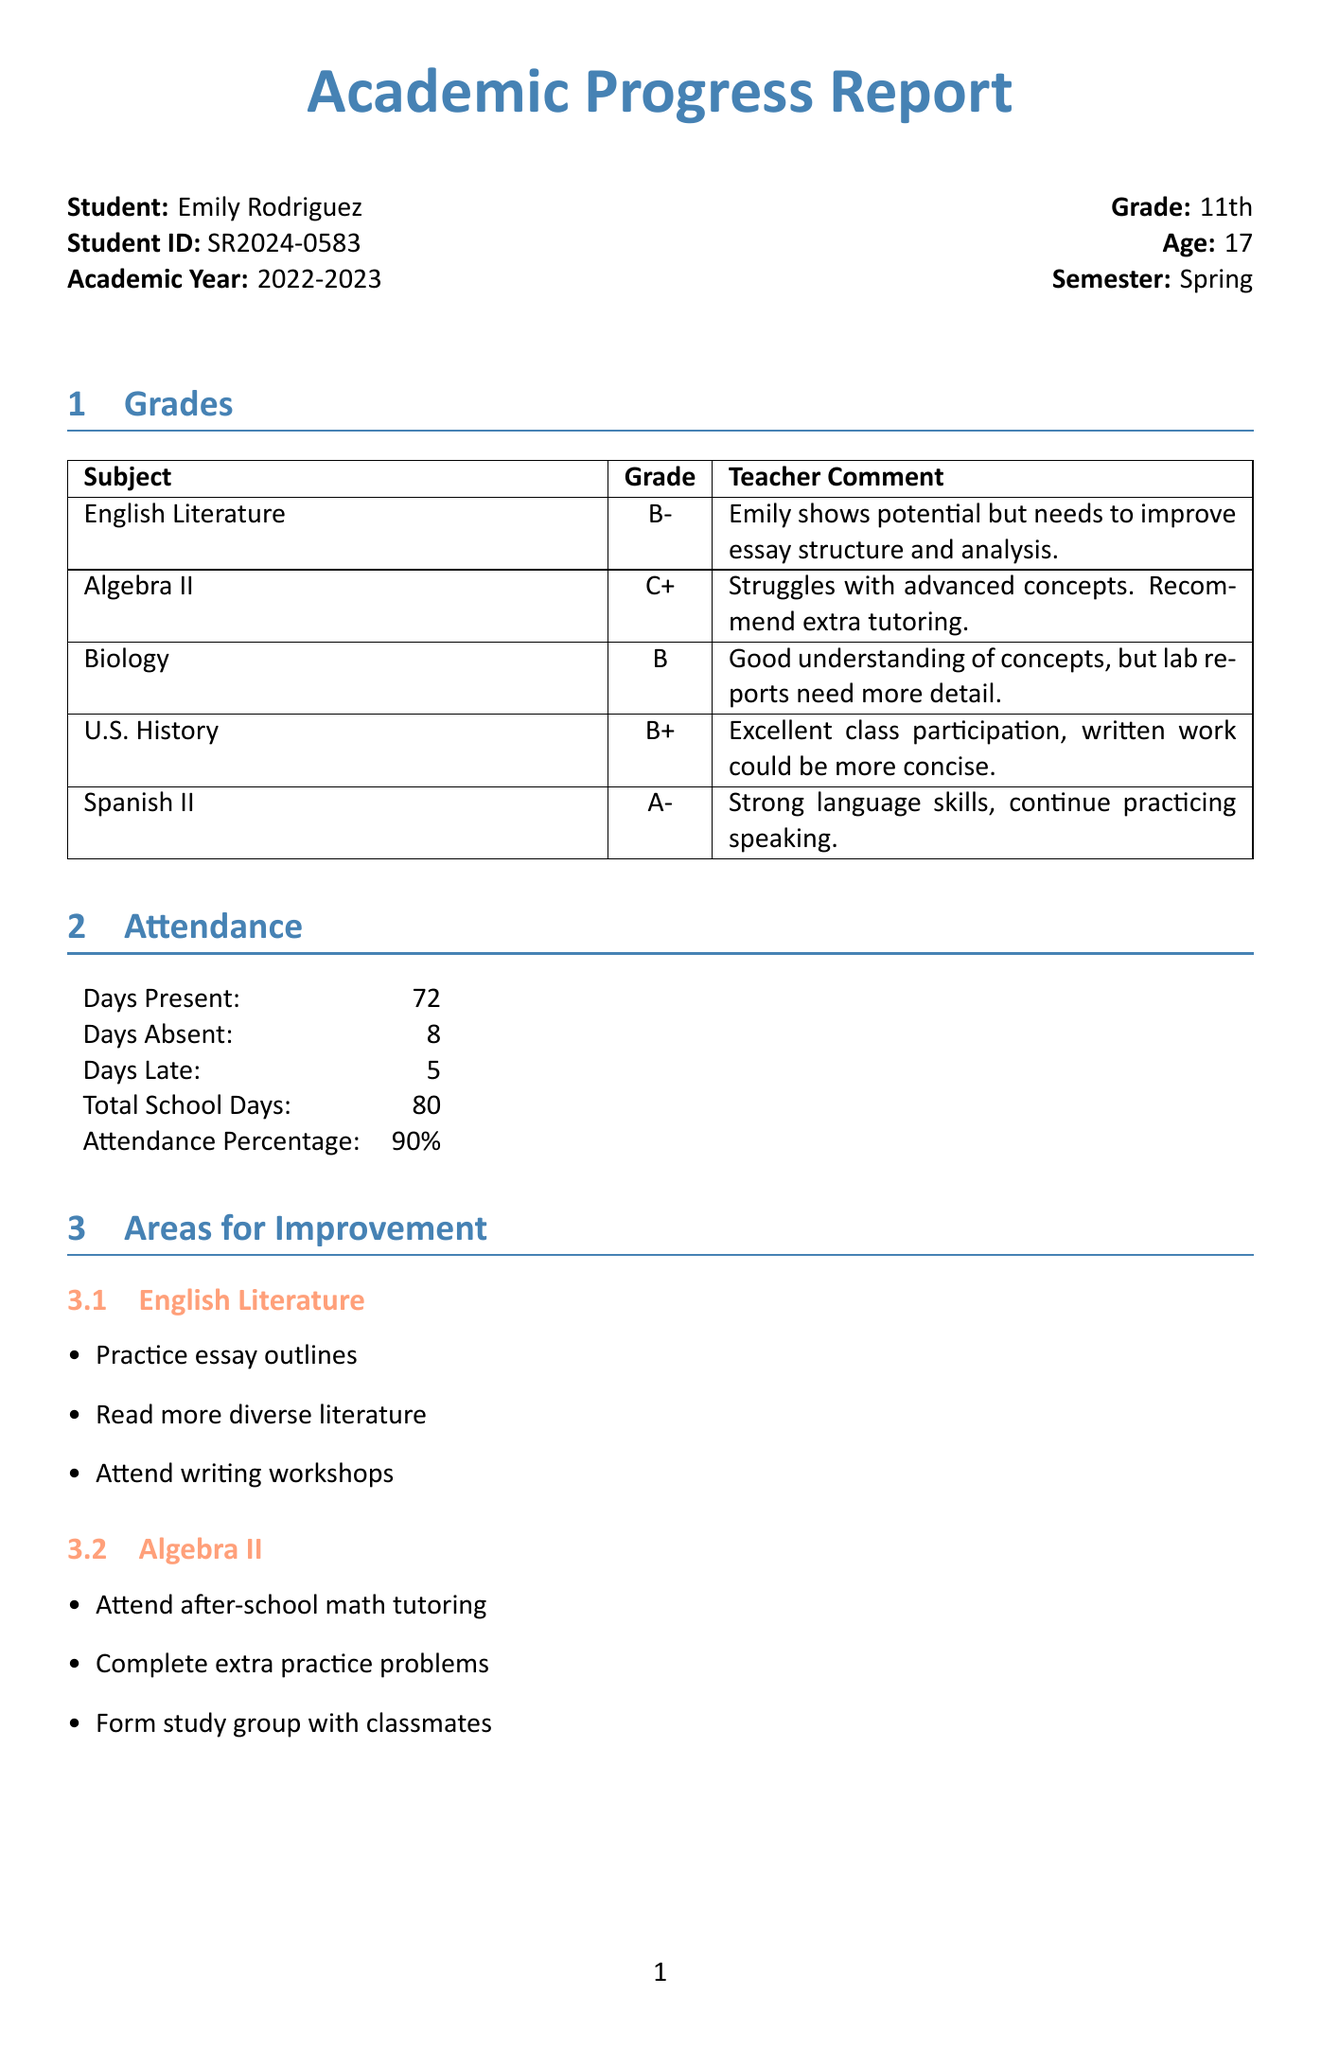What is Emily's grade in Algebra II? The document lists the grades for each subject, stating Algebra II has a grade of C+.
Answer: C+ How many days was Emily absent? The attendance section specifies the number of days absent as 8.
Answer: 8 What is the attendance percentage? The document calculates attendance based on days present and total school days, which is 90%.
Answer: 90% What are Emily's academic goals? The future goals section outlines that Emily's academic goal is to improve her overall GPA to 3.0 or higher.
Answer: Improve overall GPA to 3.0 or higher What recommendation is given for improving Algebra II? The areas for improvement section lists recommendations for Algebra II, including attending after-school math tutoring.
Answer: Attend after-school math tutoring Which subject has the highest grade? The grades section shows that Spanish II has the highest grade of A-.
Answer: A- Who teaches English Literature? The teacher notes indicate that Ms. Johnson is the teacher for English Literature.
Answer: Ms. Johnson What extracurricular activity does Emily participate in related to parenting? The extracurricular activities list mentions a Parenting Skills Workshop where Emily participated excellently.
Answer: Parenting Skills Workshop What is one recommendation from the counselor? The document includes several counselor recommendations, one of which is to consider online or hybrid learning options.
Answer: Consider online or hybrid learning options 